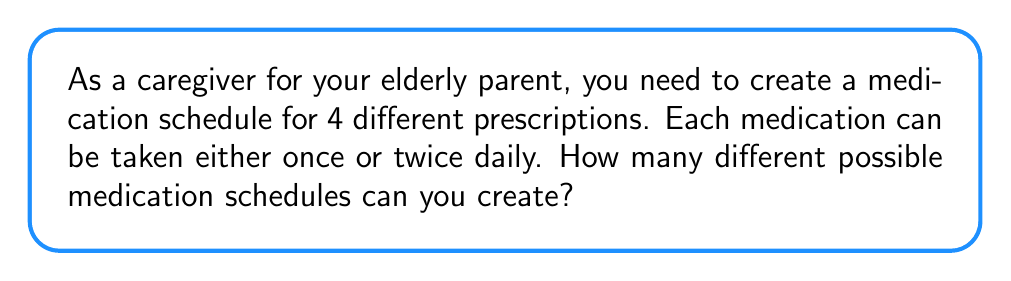Could you help me with this problem? Let's approach this step-by-step:

1) We have 4 different medications, and for each medication, we have 2 choices:
   - Take it once daily
   - Take it twice daily

2) This scenario can be modeled as a sequence of 4 independent choices, where each choice has 2 options.

3) In combinatorics, when we have a sequence of independent choices, we multiply the number of options for each choice.

4) Therefore, we can use the multiplication principle:

   $$ \text{Total number of schedules} = 2 \times 2 \times 2 \times 2 $$

5) This is equivalent to:

   $$ \text{Total number of schedules} = 2^4 $$

6) Calculating this:

   $$ 2^4 = 16 $$

Thus, there are 16 different possible medication schedules.
Answer: 16 